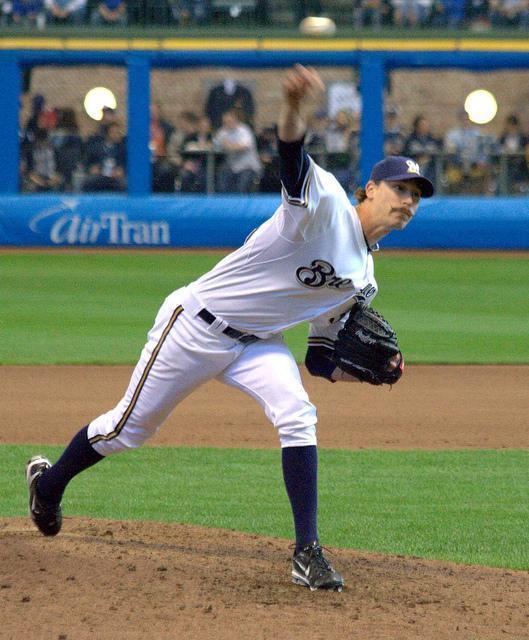To whom is this ball thrown?
Choose the right answer from the provided options to respond to the question.
Options: Infield, ref, coach, batter. Batter. 